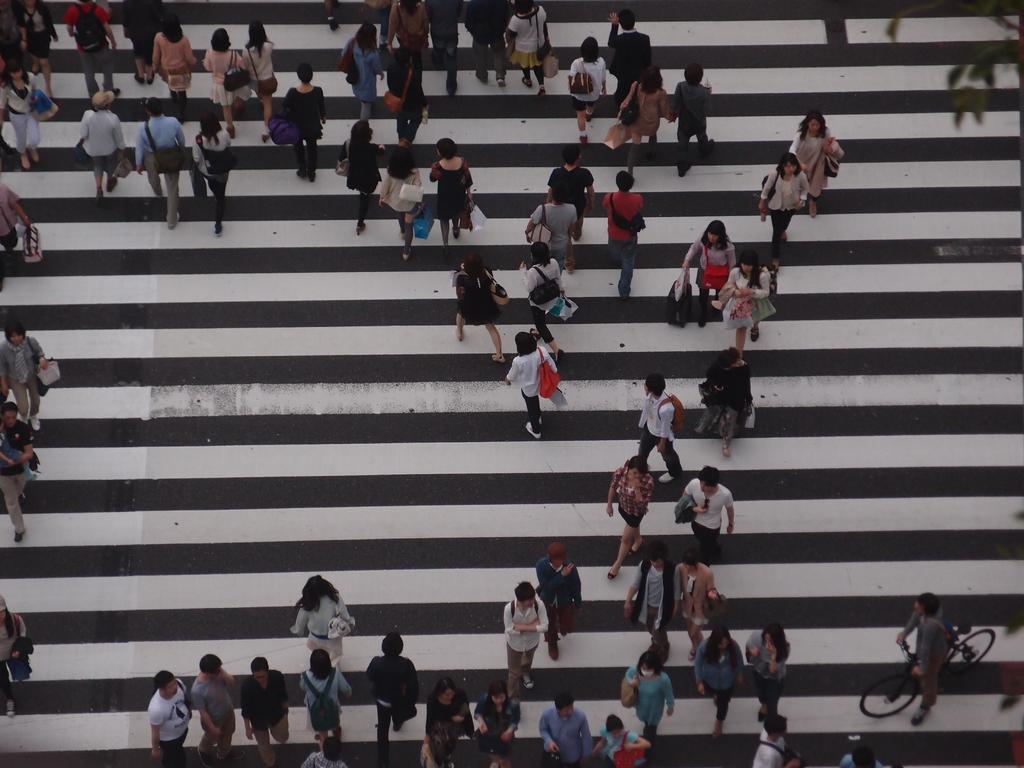In one or two sentences, can you explain what this image depicts? There are persons in different color dresses, some of them are holding bags on the zebra crossing. 